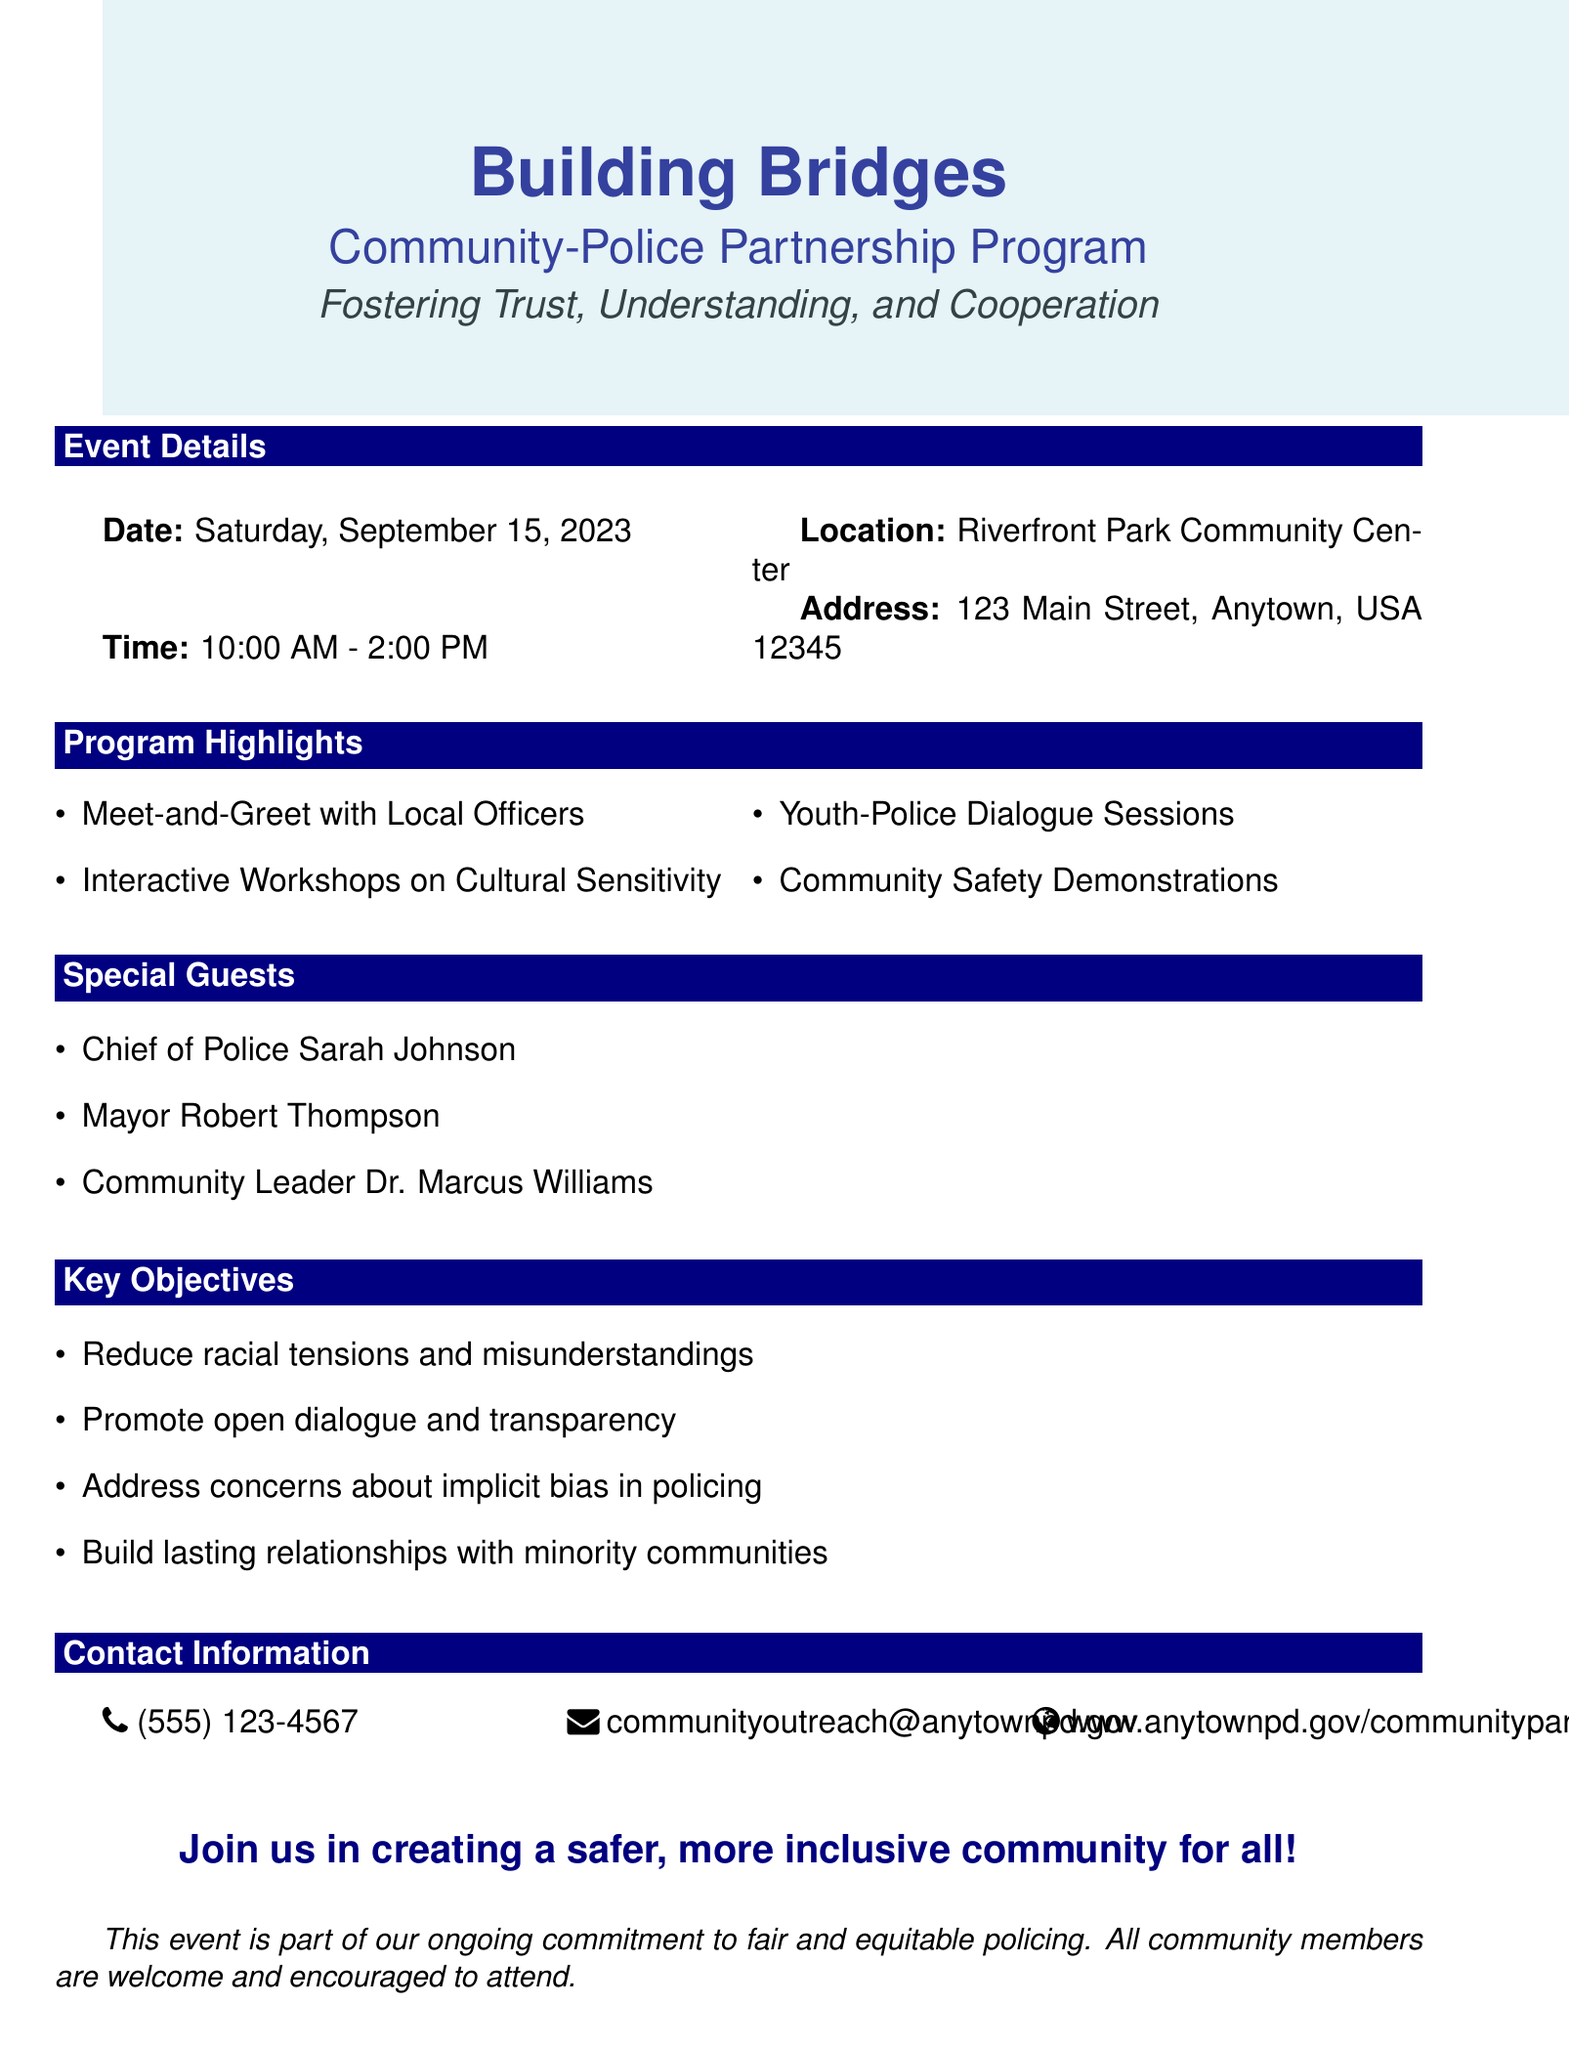What is the title of the program? The title of the program is the main heading in the document.
Answer: Building Bridges: Community-Police Partnership Program When is the event scheduled? The event date is explicitly mentioned in the document under event details.
Answer: Saturday, September 15, 2023 Where is the event taking place? The location is provided in the event details section of the document.
Answer: Riverfront Park Community Center Who is one of the special guests? The document lists special guests, and this question asks for one of them.
Answer: Chief of Police Sarah Johnson What is one of the key objectives of the program? The document outlines key objectives, requiring identification of one.
Answer: Address concerns about implicit bias in policing What time does the event start? The starting time of the event is specified in the event details section.
Answer: 10:00 AM How long is the event scheduled to last? The duration can be inferred from the start and end times given in the document.
Answer: 4 hours What is the contact email for inquiries? The contact email is provided in the contact information section.
Answer: communityoutreach@anytownpd.gov What is the call to action at the end of the document? The call to action is the concluding statement encouraging community involvement.
Answer: Join us in creating a safer, more inclusive community for all! 